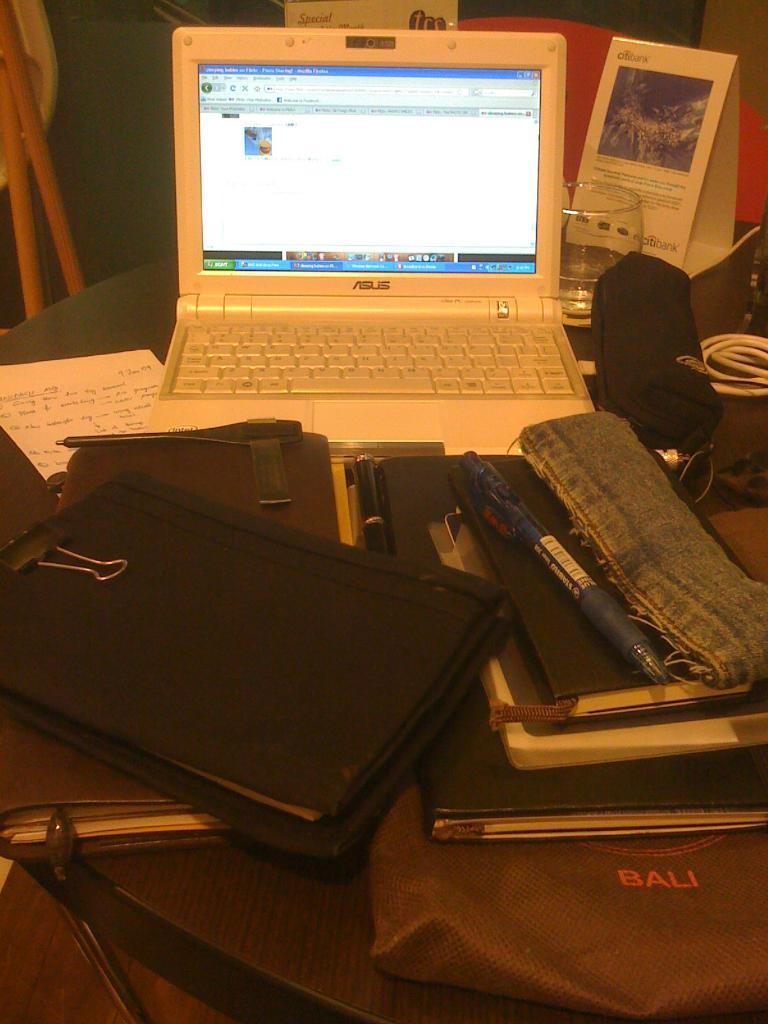<image>
Write a terse but informative summary of the picture. Asus is the brand shown on this open laptop. 